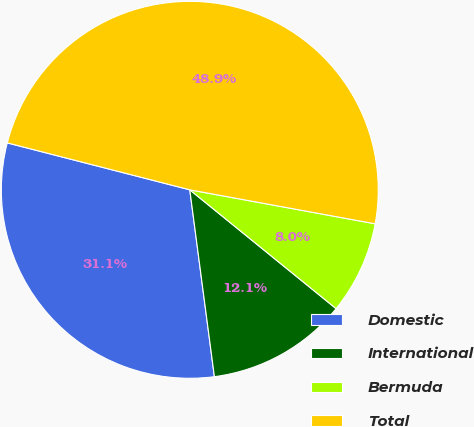Convert chart. <chart><loc_0><loc_0><loc_500><loc_500><pie_chart><fcel>Domestic<fcel>International<fcel>Bermuda<fcel>Total<nl><fcel>31.09%<fcel>12.06%<fcel>7.97%<fcel>48.88%<nl></chart> 